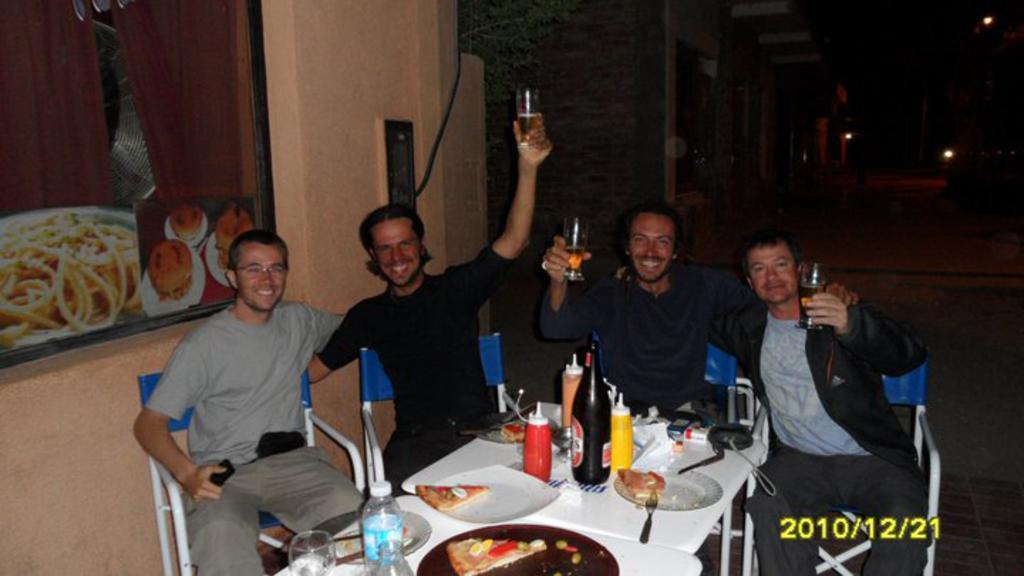Please provide a concise description of this image. In this image there are 4 people sitting in chairs and on table there are pizza slices, plates, forks, sauce bottles, wine bottle, water bottle, camera, pouch and at the back ground there is frame attached to wall, door, lights. 